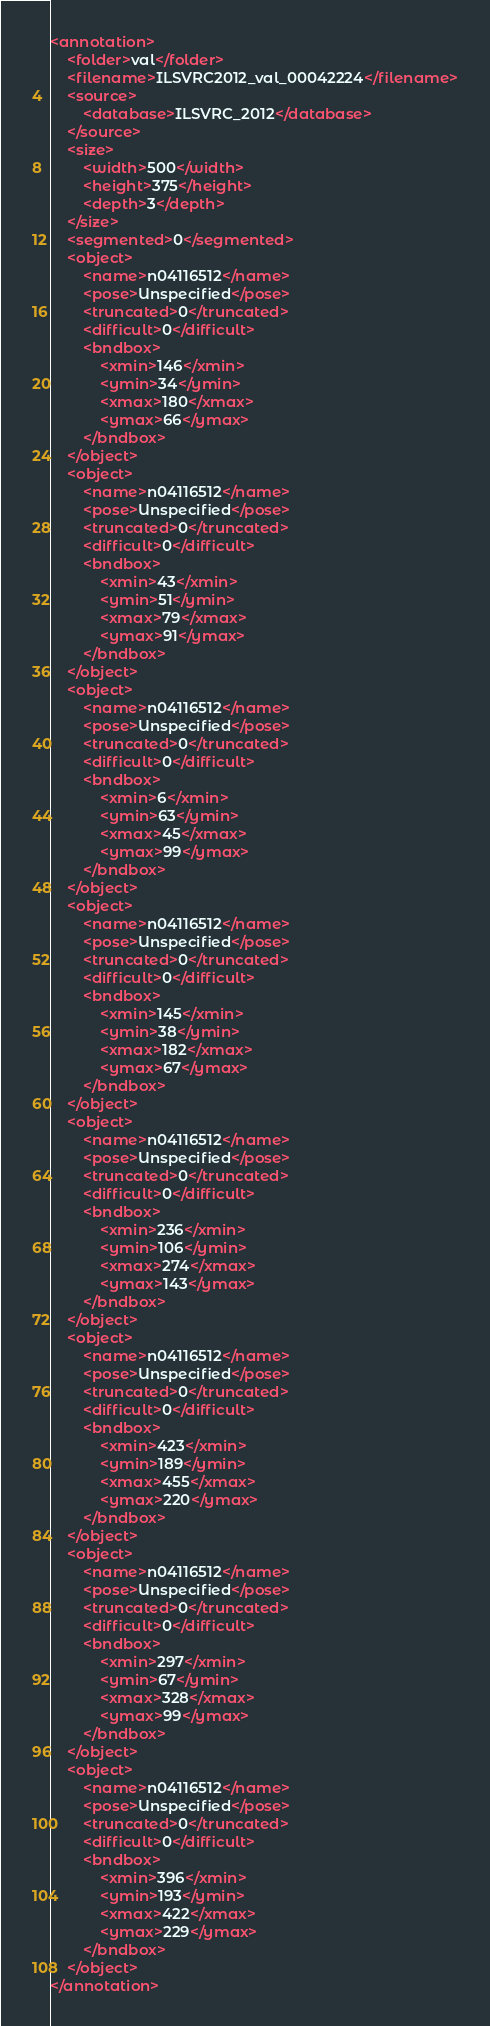<code> <loc_0><loc_0><loc_500><loc_500><_XML_><annotation>
	<folder>val</folder>
	<filename>ILSVRC2012_val_00042224</filename>
	<source>
		<database>ILSVRC_2012</database>
	</source>
	<size>
		<width>500</width>
		<height>375</height>
		<depth>3</depth>
	</size>
	<segmented>0</segmented>
	<object>
		<name>n04116512</name>
		<pose>Unspecified</pose>
		<truncated>0</truncated>
		<difficult>0</difficult>
		<bndbox>
			<xmin>146</xmin>
			<ymin>34</ymin>
			<xmax>180</xmax>
			<ymax>66</ymax>
		</bndbox>
	</object>
	<object>
		<name>n04116512</name>
		<pose>Unspecified</pose>
		<truncated>0</truncated>
		<difficult>0</difficult>
		<bndbox>
			<xmin>43</xmin>
			<ymin>51</ymin>
			<xmax>79</xmax>
			<ymax>91</ymax>
		</bndbox>
	</object>
	<object>
		<name>n04116512</name>
		<pose>Unspecified</pose>
		<truncated>0</truncated>
		<difficult>0</difficult>
		<bndbox>
			<xmin>6</xmin>
			<ymin>63</ymin>
			<xmax>45</xmax>
			<ymax>99</ymax>
		</bndbox>
	</object>
	<object>
		<name>n04116512</name>
		<pose>Unspecified</pose>
		<truncated>0</truncated>
		<difficult>0</difficult>
		<bndbox>
			<xmin>145</xmin>
			<ymin>38</ymin>
			<xmax>182</xmax>
			<ymax>67</ymax>
		</bndbox>
	</object>
	<object>
		<name>n04116512</name>
		<pose>Unspecified</pose>
		<truncated>0</truncated>
		<difficult>0</difficult>
		<bndbox>
			<xmin>236</xmin>
			<ymin>106</ymin>
			<xmax>274</xmax>
			<ymax>143</ymax>
		</bndbox>
	</object>
	<object>
		<name>n04116512</name>
		<pose>Unspecified</pose>
		<truncated>0</truncated>
		<difficult>0</difficult>
		<bndbox>
			<xmin>423</xmin>
			<ymin>189</ymin>
			<xmax>455</xmax>
			<ymax>220</ymax>
		</bndbox>
	</object>
	<object>
		<name>n04116512</name>
		<pose>Unspecified</pose>
		<truncated>0</truncated>
		<difficult>0</difficult>
		<bndbox>
			<xmin>297</xmin>
			<ymin>67</ymin>
			<xmax>328</xmax>
			<ymax>99</ymax>
		</bndbox>
	</object>
	<object>
		<name>n04116512</name>
		<pose>Unspecified</pose>
		<truncated>0</truncated>
		<difficult>0</difficult>
		<bndbox>
			<xmin>396</xmin>
			<ymin>193</ymin>
			<xmax>422</xmax>
			<ymax>229</ymax>
		</bndbox>
	</object>
</annotation></code> 